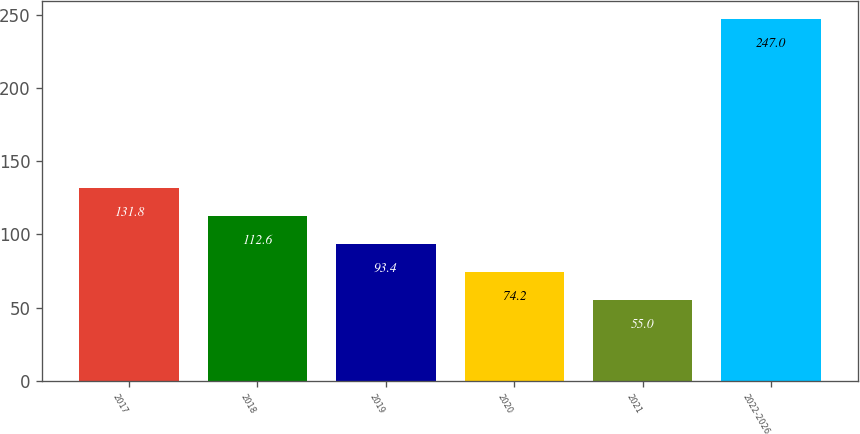Convert chart to OTSL. <chart><loc_0><loc_0><loc_500><loc_500><bar_chart><fcel>2017<fcel>2018<fcel>2019<fcel>2020<fcel>2021<fcel>2022-2026<nl><fcel>131.8<fcel>112.6<fcel>93.4<fcel>74.2<fcel>55<fcel>247<nl></chart> 